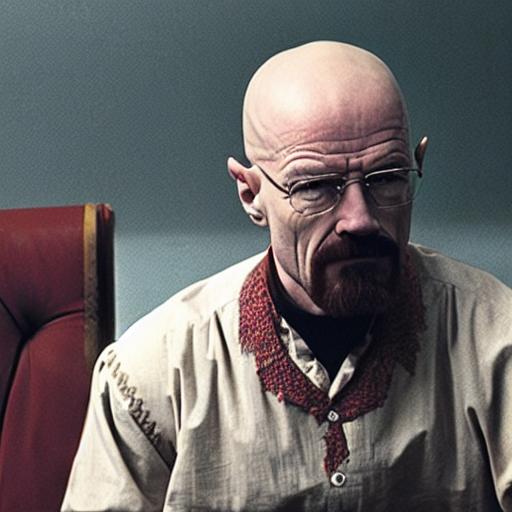What does the background consist of?
A. Blue-gray blocks.
B. Detailed elements
C. Colorful patterns
Answer with the option's letter from the given choices directly. The background consists of blue-gray blocks which give off a simplistic yet gritty atmosphere, complementing the austere and serious expression of the individual in the foreground. 